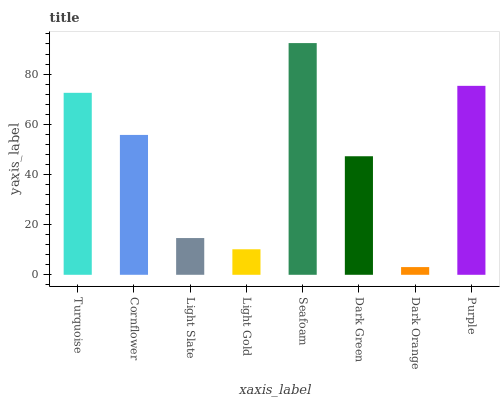Is Dark Orange the minimum?
Answer yes or no. Yes. Is Seafoam the maximum?
Answer yes or no. Yes. Is Cornflower the minimum?
Answer yes or no. No. Is Cornflower the maximum?
Answer yes or no. No. Is Turquoise greater than Cornflower?
Answer yes or no. Yes. Is Cornflower less than Turquoise?
Answer yes or no. Yes. Is Cornflower greater than Turquoise?
Answer yes or no. No. Is Turquoise less than Cornflower?
Answer yes or no. No. Is Cornflower the high median?
Answer yes or no. Yes. Is Dark Green the low median?
Answer yes or no. Yes. Is Seafoam the high median?
Answer yes or no. No. Is Cornflower the low median?
Answer yes or no. No. 